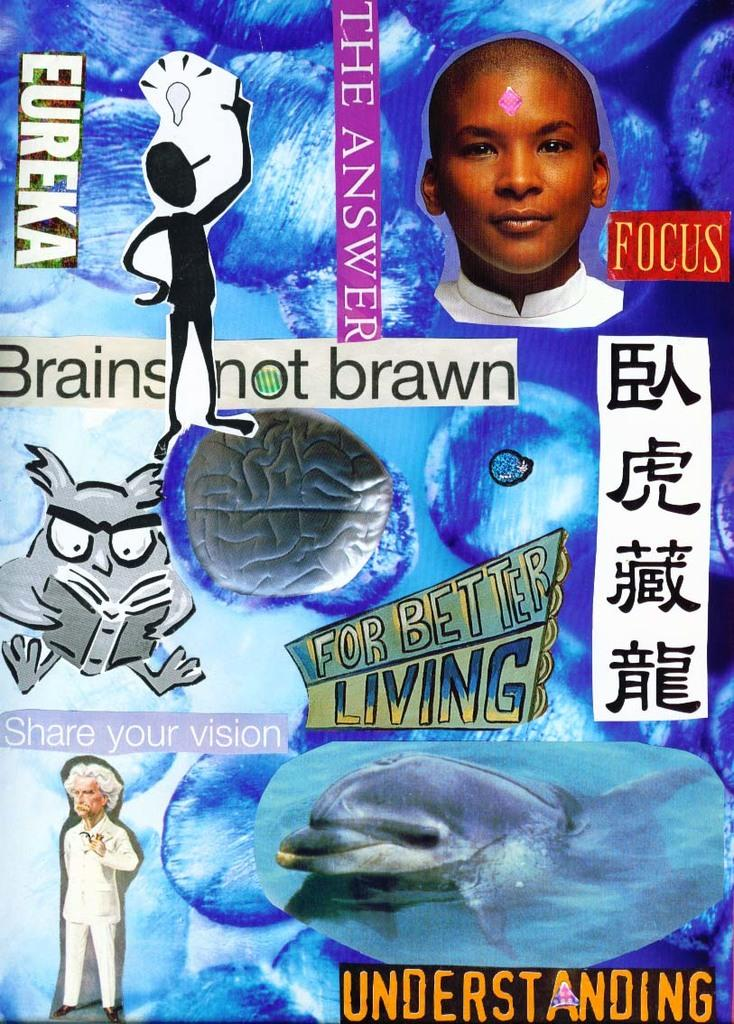What type of editing has been done to the image? The image is edited, but the specific type of editing is not mentioned in the facts. What else can be found in the image besides the edited content? There is text and cartoons in the image. How does the crook in the image affect the sleeping character? There is no crook or sleeping character present in the image. What is the increase in the number of cartoons in the image? The facts do not mention any increase in the number of cartoons in the image. 